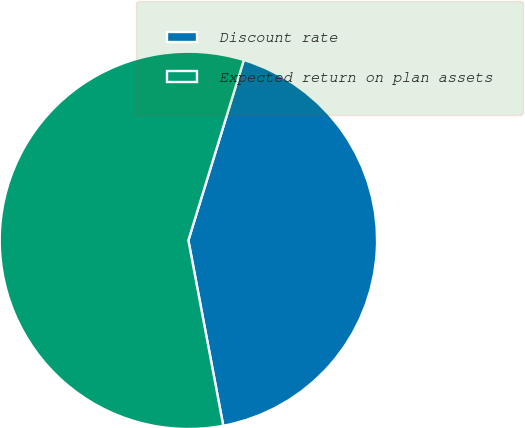Convert chart to OTSL. <chart><loc_0><loc_0><loc_500><loc_500><pie_chart><fcel>Discount rate<fcel>Expected return on plan assets<nl><fcel>42.29%<fcel>57.71%<nl></chart> 